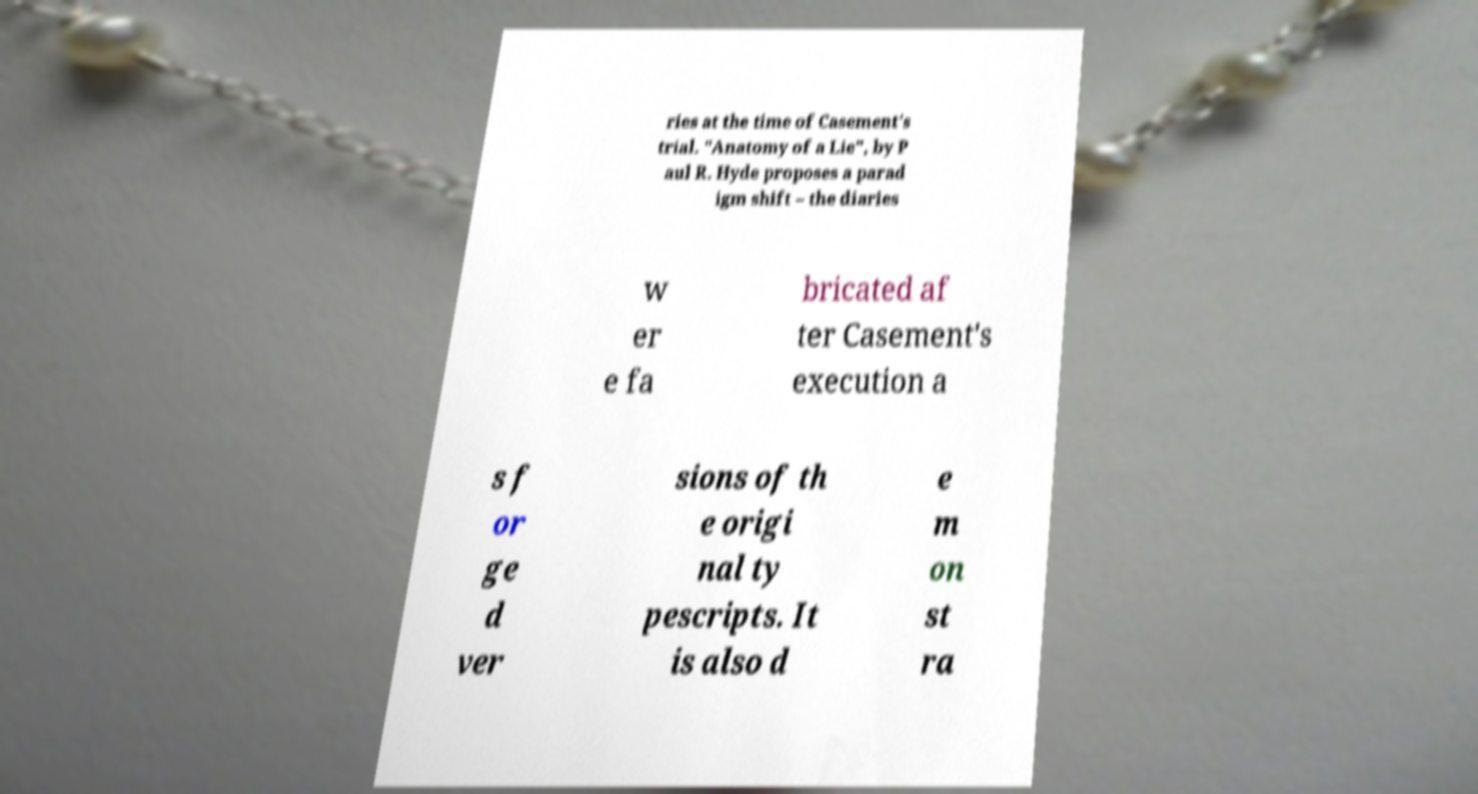Please identify and transcribe the text found in this image. ries at the time of Casement's trial. "Anatomy of a Lie", by P aul R. Hyde proposes a parad igm shift – the diaries w er e fa bricated af ter Casement's execution a s f or ge d ver sions of th e origi nal ty pescripts. It is also d e m on st ra 